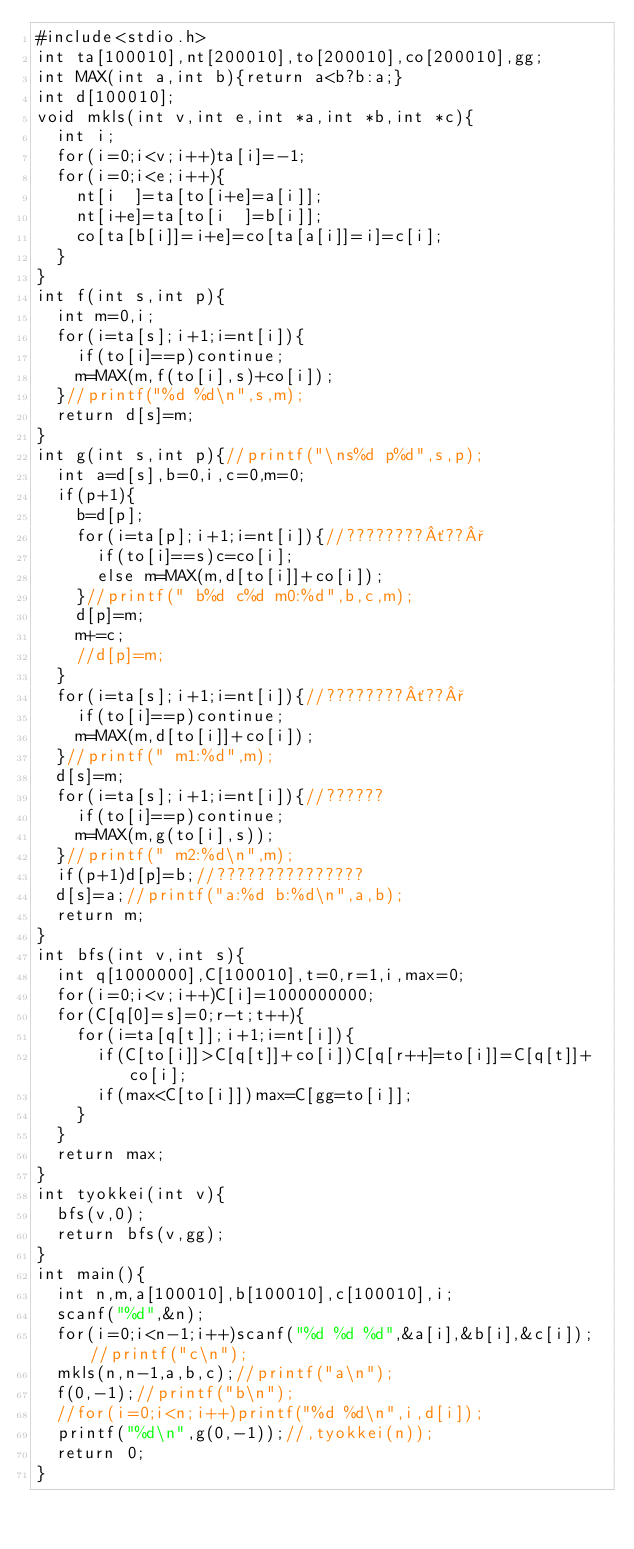Convert code to text. <code><loc_0><loc_0><loc_500><loc_500><_C_>#include<stdio.h>
int ta[100010],nt[200010],to[200010],co[200010],gg;
int MAX(int a,int b){return a<b?b:a;}
int d[100010];
void mkls(int v,int e,int *a,int *b,int *c){
  int i;
  for(i=0;i<v;i++)ta[i]=-1;
  for(i=0;i<e;i++){
    nt[i  ]=ta[to[i+e]=a[i]];
    nt[i+e]=ta[to[i  ]=b[i]];
    co[ta[b[i]]=i+e]=co[ta[a[i]]=i]=c[i];
  }
}
int f(int s,int p){
  int m=0,i;
  for(i=ta[s];i+1;i=nt[i]){
    if(to[i]==p)continue;
    m=MAX(m,f(to[i],s)+co[i]);
  }//printf("%d %d\n",s,m);
  return d[s]=m;
}
int g(int s,int p){//printf("\ns%d p%d",s,p);
  int a=d[s],b=0,i,c=0,m=0;
  if(p+1){
    b=d[p];
    for(i=ta[p];i+1;i=nt[i]){//????????´??°
      if(to[i]==s)c=co[i];
      else m=MAX(m,d[to[i]]+co[i]);
    }//printf(" b%d c%d m0:%d",b,c,m);
    d[p]=m;
    m+=c;
    //d[p]=m;
  }
  for(i=ta[s];i+1;i=nt[i]){//????????´??°
    if(to[i]==p)continue;
    m=MAX(m,d[to[i]]+co[i]);
  }//printf(" m1:%d",m);
  d[s]=m;
  for(i=ta[s];i+1;i=nt[i]){//??????
    if(to[i]==p)continue;
    m=MAX(m,g(to[i],s));
  }//printf(" m2:%d\n",m);
  if(p+1)d[p]=b;//???????????????
  d[s]=a;//printf("a:%d b:%d\n",a,b);
  return m;
}
int bfs(int v,int s){
  int q[1000000],C[100010],t=0,r=1,i,max=0;
  for(i=0;i<v;i++)C[i]=1000000000;
  for(C[q[0]=s]=0;r-t;t++){
    for(i=ta[q[t]];i+1;i=nt[i]){
      if(C[to[i]]>C[q[t]]+co[i])C[q[r++]=to[i]]=C[q[t]]+co[i];
      if(max<C[to[i]])max=C[gg=to[i]];
    }
  }
  return max;
}
int tyokkei(int v){
  bfs(v,0);
  return bfs(v,gg);
}
int main(){
  int n,m,a[100010],b[100010],c[100010],i;
  scanf("%d",&n);
  for(i=0;i<n-1;i++)scanf("%d %d %d",&a[i],&b[i],&c[i]);//printf("c\n");
  mkls(n,n-1,a,b,c);//printf("a\n");
  f(0,-1);//printf("b\n");
  //for(i=0;i<n;i++)printf("%d %d\n",i,d[i]);
  printf("%d\n",g(0,-1));//,tyokkei(n));
  return 0;
}</code> 